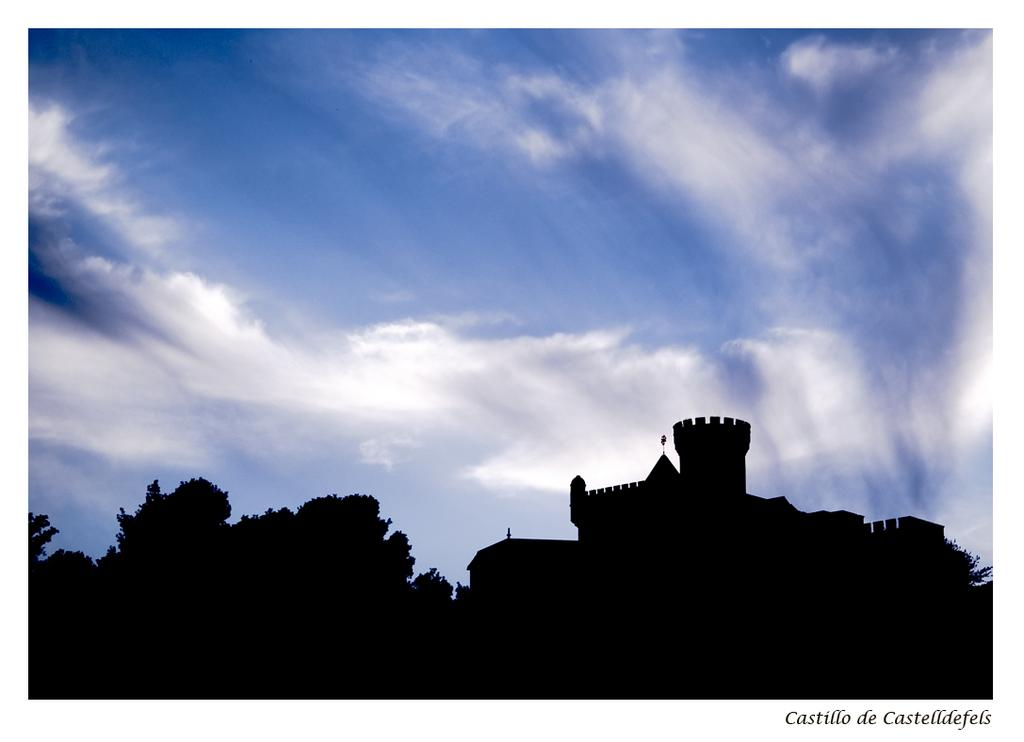What type of structure is visible in the image? There is a fort in the image. What natural elements can be seen in the image? There are trees and clouds visible in the image. Is there any text or marking at the bottom of the image? Yes, there is a watermark at the bottom of the image. Can you tell me the year when the snail was last seen near the fort in the image? There is no snail present in the image, so it is not possible to determine when it was last seen near the fort. 